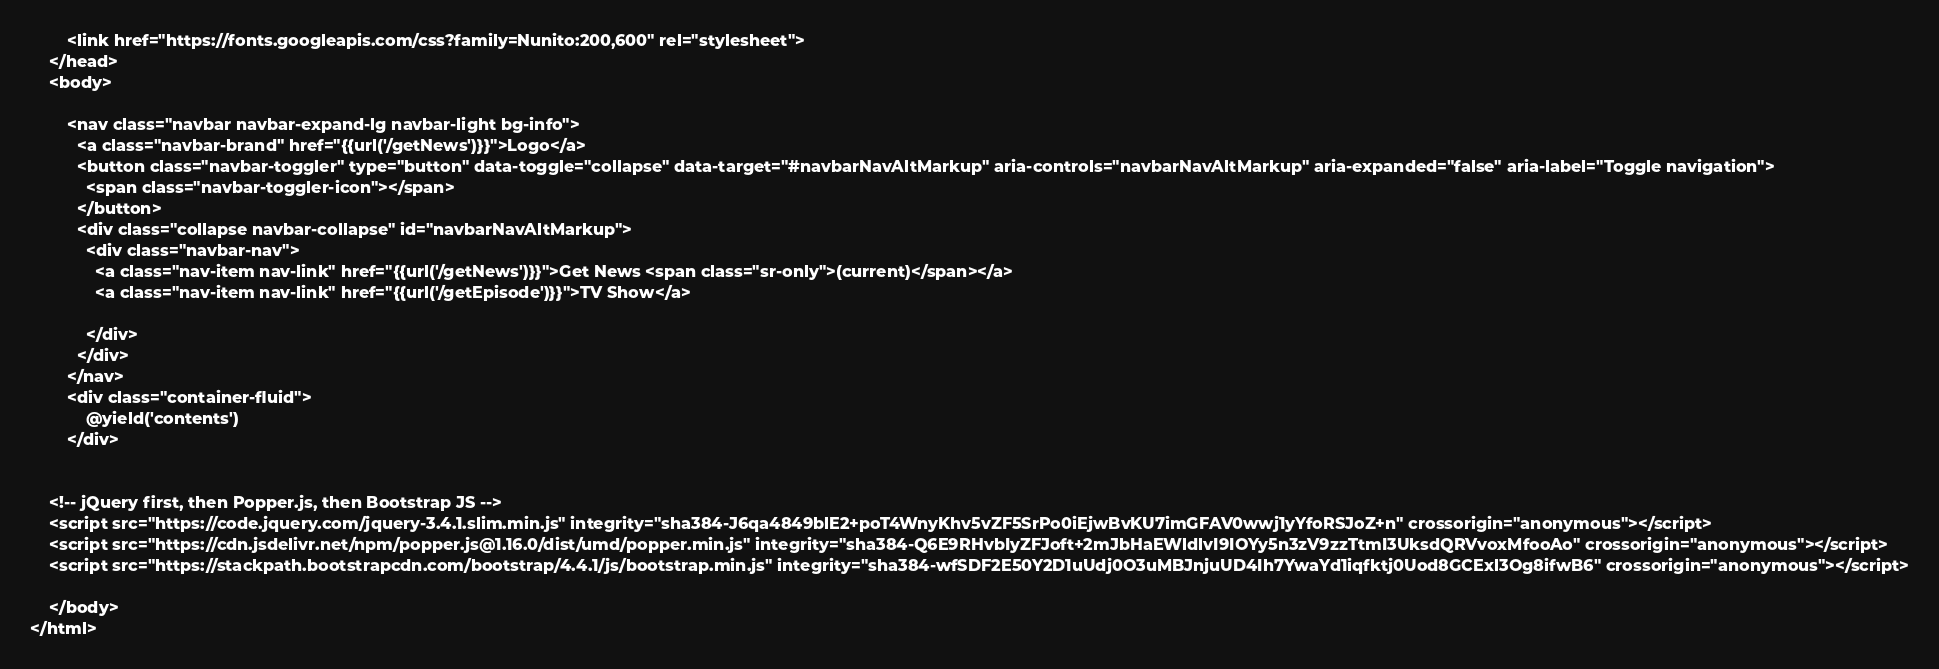Convert code to text. <code><loc_0><loc_0><loc_500><loc_500><_PHP_>        <link href="https://fonts.googleapis.com/css?family=Nunito:200,600" rel="stylesheet">
    </head>
    <body>
        
        <nav class="navbar navbar-expand-lg navbar-light bg-info">
          <a class="navbar-brand" href="{{url('/getNews')}}">Logo</a>
          <button class="navbar-toggler" type="button" data-toggle="collapse" data-target="#navbarNavAltMarkup" aria-controls="navbarNavAltMarkup" aria-expanded="false" aria-label="Toggle navigation">
            <span class="navbar-toggler-icon"></span>
          </button>
          <div class="collapse navbar-collapse" id="navbarNavAltMarkup">
            <div class="navbar-nav">
              <a class="nav-item nav-link" href="{{url('/getNews')}}">Get News <span class="sr-only">(current)</span></a>
              <a class="nav-item nav-link" href="{{url('/getEpisode')}}">TV Show</a>
              
            </div>
          </div>
        </nav>
        <div class="container-fluid">
            @yield('contents')
        </div>


    <!-- jQuery first, then Popper.js, then Bootstrap JS -->
    <script src="https://code.jquery.com/jquery-3.4.1.slim.min.js" integrity="sha384-J6qa4849blE2+poT4WnyKhv5vZF5SrPo0iEjwBvKU7imGFAV0wwj1yYfoRSJoZ+n" crossorigin="anonymous"></script>
    <script src="https://cdn.jsdelivr.net/npm/popper.js@1.16.0/dist/umd/popper.min.js" integrity="sha384-Q6E9RHvbIyZFJoft+2mJbHaEWldlvI9IOYy5n3zV9zzTtmI3UksdQRVvoxMfooAo" crossorigin="anonymous"></script>
    <script src="https://stackpath.bootstrapcdn.com/bootstrap/4.4.1/js/bootstrap.min.js" integrity="sha384-wfSDF2E50Y2D1uUdj0O3uMBJnjuUD4Ih7YwaYd1iqfktj0Uod8GCExl3Og8ifwB6" crossorigin="anonymous"></script>

    </body>
</html>
</code> 